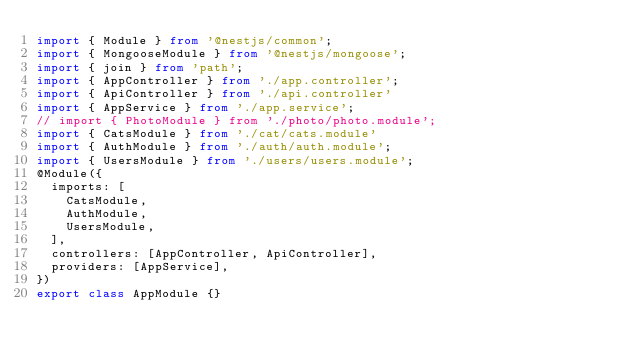<code> <loc_0><loc_0><loc_500><loc_500><_TypeScript_>import { Module } from '@nestjs/common';
import { MongooseModule } from '@nestjs/mongoose';
import { join } from 'path';
import { AppController } from './app.controller';
import { ApiController } from './api.controller'
import { AppService } from './app.service';
// import { PhotoModule } from './photo/photo.module';
import { CatsModule } from './cat/cats.module'
import { AuthModule } from './auth/auth.module';
import { UsersModule } from './users/users.module';
@Module({
  imports: [
    CatsModule,
    AuthModule,
    UsersModule,
  ],
  controllers: [AppController, ApiController],
  providers: [AppService],
})
export class AppModule {}
</code> 